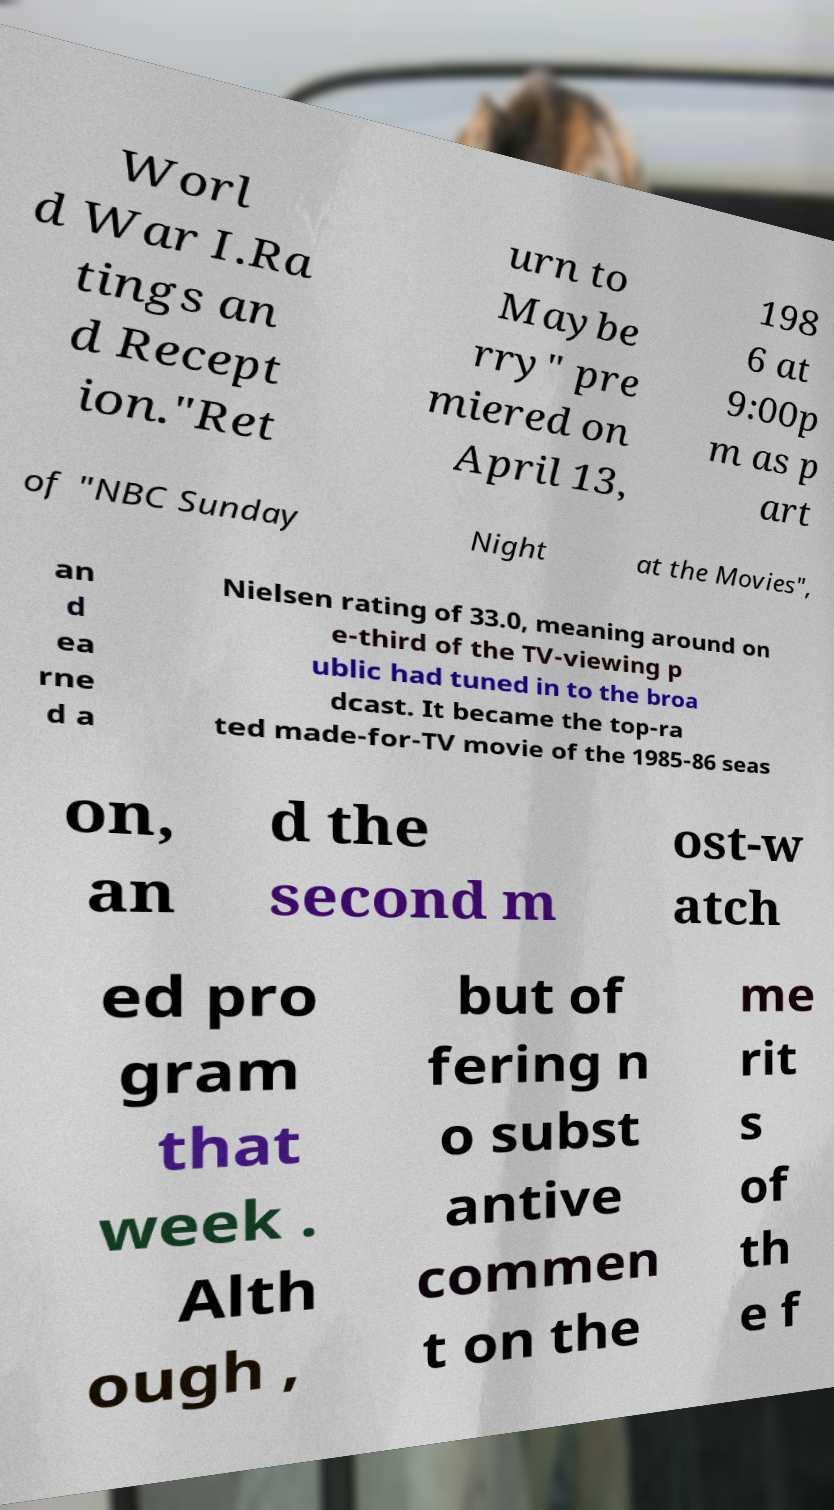Please read and relay the text visible in this image. What does it say? Worl d War I.Ra tings an d Recept ion."Ret urn to Maybe rry" pre miered on April 13, 198 6 at 9:00p m as p art of "NBC Sunday Night at the Movies", an d ea rne d a Nielsen rating of 33.0, meaning around on e-third of the TV-viewing p ublic had tuned in to the broa dcast. It became the top-ra ted made-for-TV movie of the 1985-86 seas on, an d the second m ost-w atch ed pro gram that week . Alth ough , but of fering n o subst antive commen t on the me rit s of th e f 